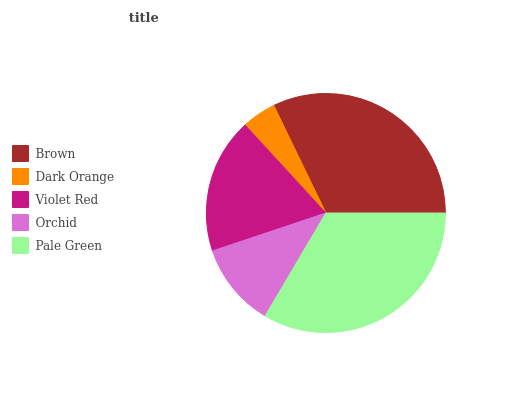Is Dark Orange the minimum?
Answer yes or no. Yes. Is Pale Green the maximum?
Answer yes or no. Yes. Is Violet Red the minimum?
Answer yes or no. No. Is Violet Red the maximum?
Answer yes or no. No. Is Violet Red greater than Dark Orange?
Answer yes or no. Yes. Is Dark Orange less than Violet Red?
Answer yes or no. Yes. Is Dark Orange greater than Violet Red?
Answer yes or no. No. Is Violet Red less than Dark Orange?
Answer yes or no. No. Is Violet Red the high median?
Answer yes or no. Yes. Is Violet Red the low median?
Answer yes or no. Yes. Is Brown the high median?
Answer yes or no. No. Is Orchid the low median?
Answer yes or no. No. 